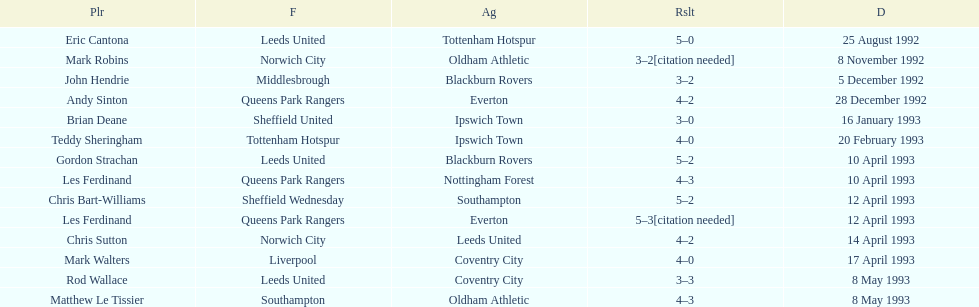Would you mind parsing the complete table? {'header': ['Plr', 'F', 'Ag', 'Rslt', 'D'], 'rows': [['Eric Cantona', 'Leeds United', 'Tottenham Hotspur', '5–0', '25 August 1992'], ['Mark Robins', 'Norwich City', 'Oldham Athletic', '3–2[citation needed]', '8 November 1992'], ['John Hendrie', 'Middlesbrough', 'Blackburn Rovers', '3–2', '5 December 1992'], ['Andy Sinton', 'Queens Park Rangers', 'Everton', '4–2', '28 December 1992'], ['Brian Deane', 'Sheffield United', 'Ipswich Town', '3–0', '16 January 1993'], ['Teddy Sheringham', 'Tottenham Hotspur', 'Ipswich Town', '4–0', '20 February 1993'], ['Gordon Strachan', 'Leeds United', 'Blackburn Rovers', '5–2', '10 April 1993'], ['Les Ferdinand', 'Queens Park Rangers', 'Nottingham Forest', '4–3', '10 April 1993'], ['Chris Bart-Williams', 'Sheffield Wednesday', 'Southampton', '5–2', '12 April 1993'], ['Les Ferdinand', 'Queens Park Rangers', 'Everton', '5–3[citation needed]', '12 April 1993'], ['Chris Sutton', 'Norwich City', 'Leeds United', '4–2', '14 April 1993'], ['Mark Walters', 'Liverpool', 'Coventry City', '4–0', '17 April 1993'], ['Rod Wallace', 'Leeds United', 'Coventry City', '3–3', '8 May 1993'], ['Matthew Le Tissier', 'Southampton', 'Oldham Athletic', '4–3', '8 May 1993']]} Southampton played on may 8th, 1993, who was their opponent? Oldham Athletic. 